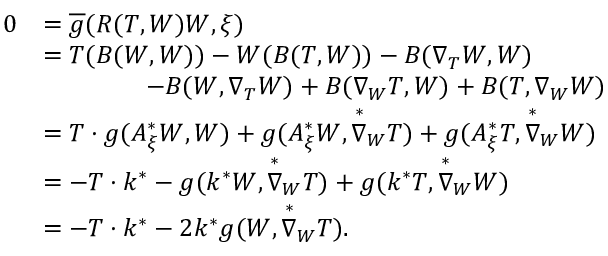Convert formula to latex. <formula><loc_0><loc_0><loc_500><loc_500>\begin{array} { r l } { 0 } & { = \overline { g } ( R ( T , W ) W , \xi ) } \\ & { = T ( B ( W , W ) ) - W ( B ( T , W ) ) - B ( \nabla _ { T } W , W ) } \\ & { \quad - B ( W , \nabla _ { T } W ) + B ( \nabla _ { W } T , W ) + B ( T , \nabla _ { W } W ) } \\ & { = T \cdot g ( A _ { \xi } ^ { * } W , W ) + g ( A _ { \xi } ^ { * } W , \overset { * } { \nabla } _ { W } T ) + g ( A _ { \xi } ^ { * } T , \overset { * } { \nabla } _ { W } W ) } \\ & { = - T \cdot k ^ { * } - g ( k ^ { * } W , \overset { * } { \nabla } _ { W } T ) + g ( k ^ { * } T , \overset { * } { \nabla } _ { W } W ) } \\ & { = - T \cdot k ^ { * } - 2 k ^ { * } g ( W , \overset { * } { \nabla } _ { W } T ) . } \end{array}</formula> 